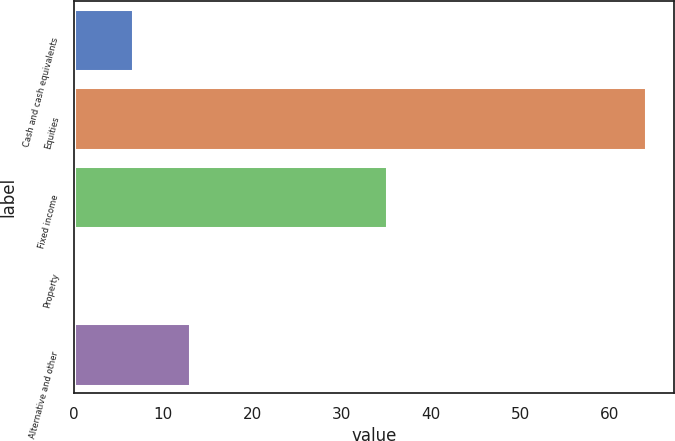Convert chart. <chart><loc_0><loc_0><loc_500><loc_500><bar_chart><fcel>Cash and cash equivalents<fcel>Equities<fcel>Fixed income<fcel>Property<fcel>Alternative and other<nl><fcel>6.68<fcel>64<fcel>35<fcel>0.31<fcel>13.05<nl></chart> 